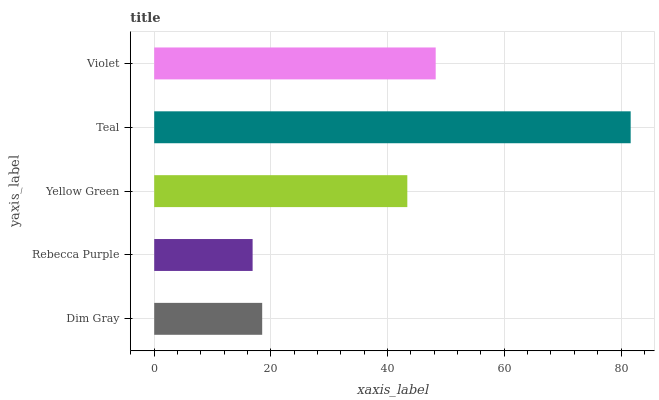Is Rebecca Purple the minimum?
Answer yes or no. Yes. Is Teal the maximum?
Answer yes or no. Yes. Is Yellow Green the minimum?
Answer yes or no. No. Is Yellow Green the maximum?
Answer yes or no. No. Is Yellow Green greater than Rebecca Purple?
Answer yes or no. Yes. Is Rebecca Purple less than Yellow Green?
Answer yes or no. Yes. Is Rebecca Purple greater than Yellow Green?
Answer yes or no. No. Is Yellow Green less than Rebecca Purple?
Answer yes or no. No. Is Yellow Green the high median?
Answer yes or no. Yes. Is Yellow Green the low median?
Answer yes or no. Yes. Is Dim Gray the high median?
Answer yes or no. No. Is Rebecca Purple the low median?
Answer yes or no. No. 